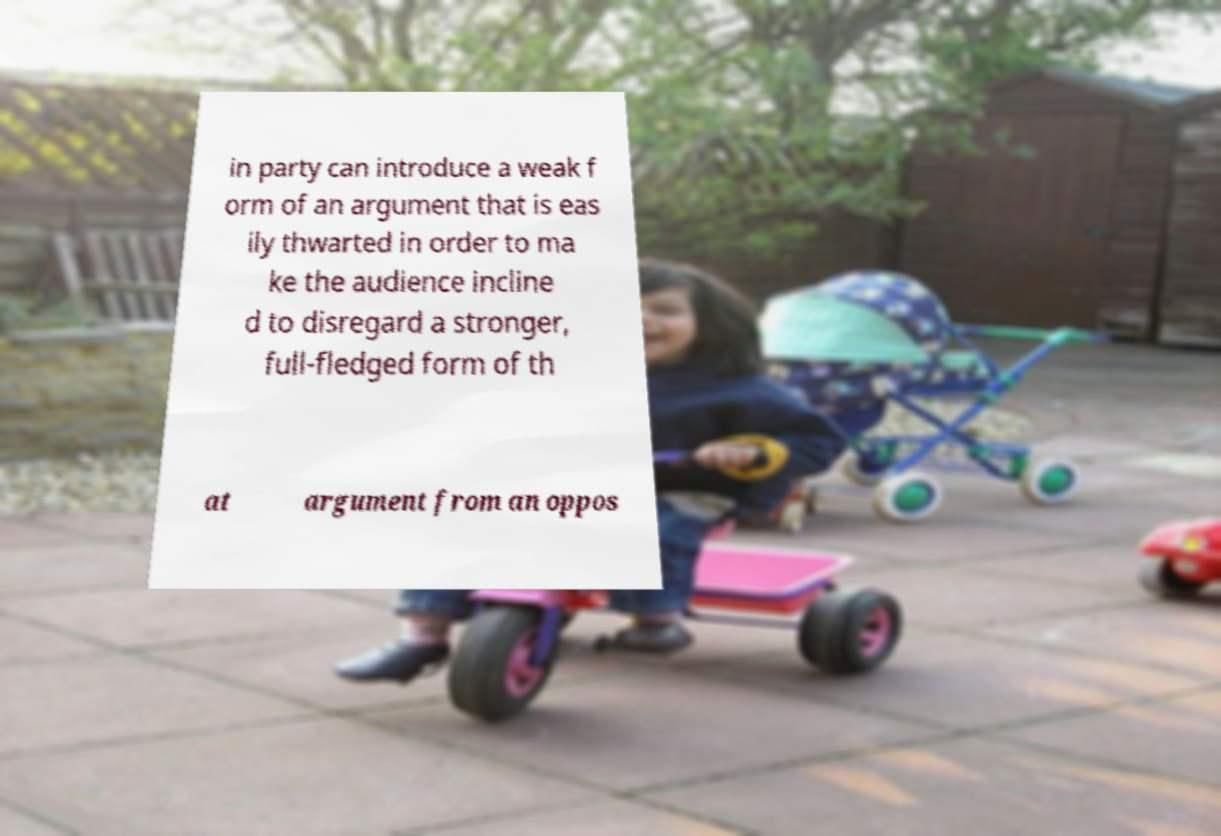What messages or text are displayed in this image? I need them in a readable, typed format. in party can introduce a weak f orm of an argument that is eas ily thwarted in order to ma ke the audience incline d to disregard a stronger, full-fledged form of th at argument from an oppos 